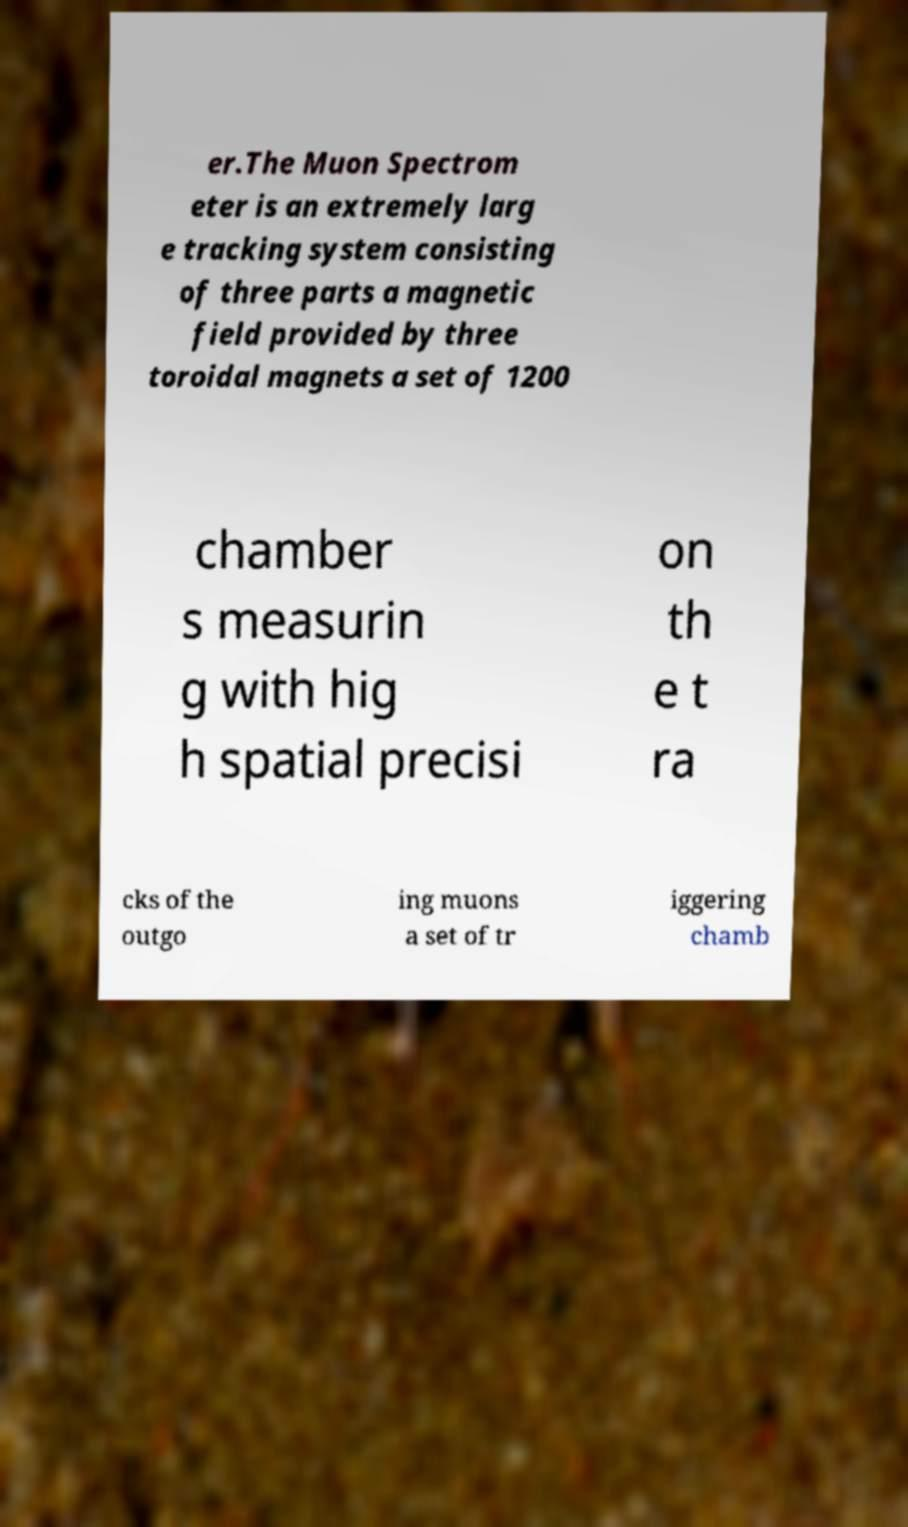Can you read and provide the text displayed in the image?This photo seems to have some interesting text. Can you extract and type it out for me? er.The Muon Spectrom eter is an extremely larg e tracking system consisting of three parts a magnetic field provided by three toroidal magnets a set of 1200 chamber s measurin g with hig h spatial precisi on th e t ra cks of the outgo ing muons a set of tr iggering chamb 